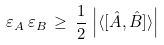Convert formula to latex. <formula><loc_0><loc_0><loc_500><loc_500>\varepsilon _ { A } \, \varepsilon _ { B } \, \geq \, { \frac { 1 } { 2 } } \, \left | \langle [ { \hat { A } } , { \hat { B } } ] \rangle \right |</formula> 